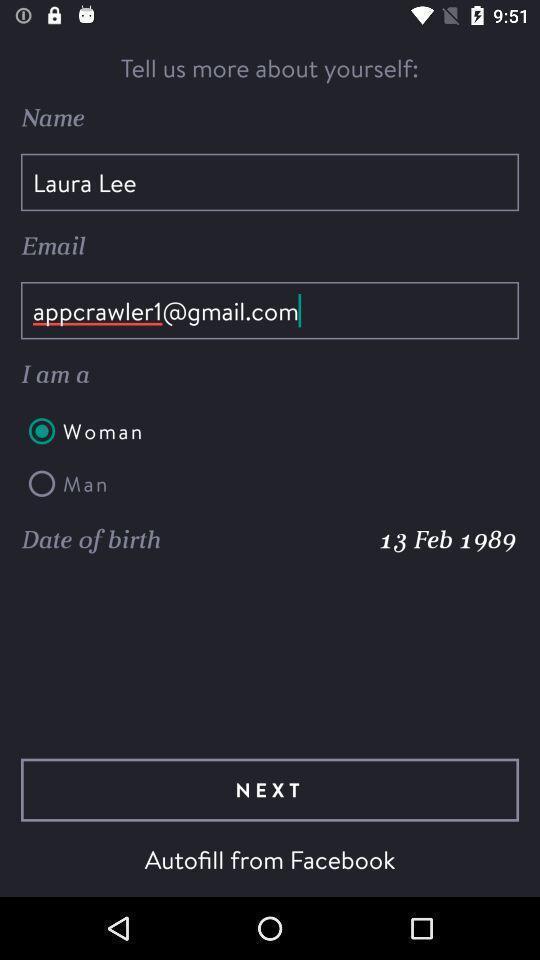Describe the key features of this screenshot. Screen showing tell us more about yourself. 